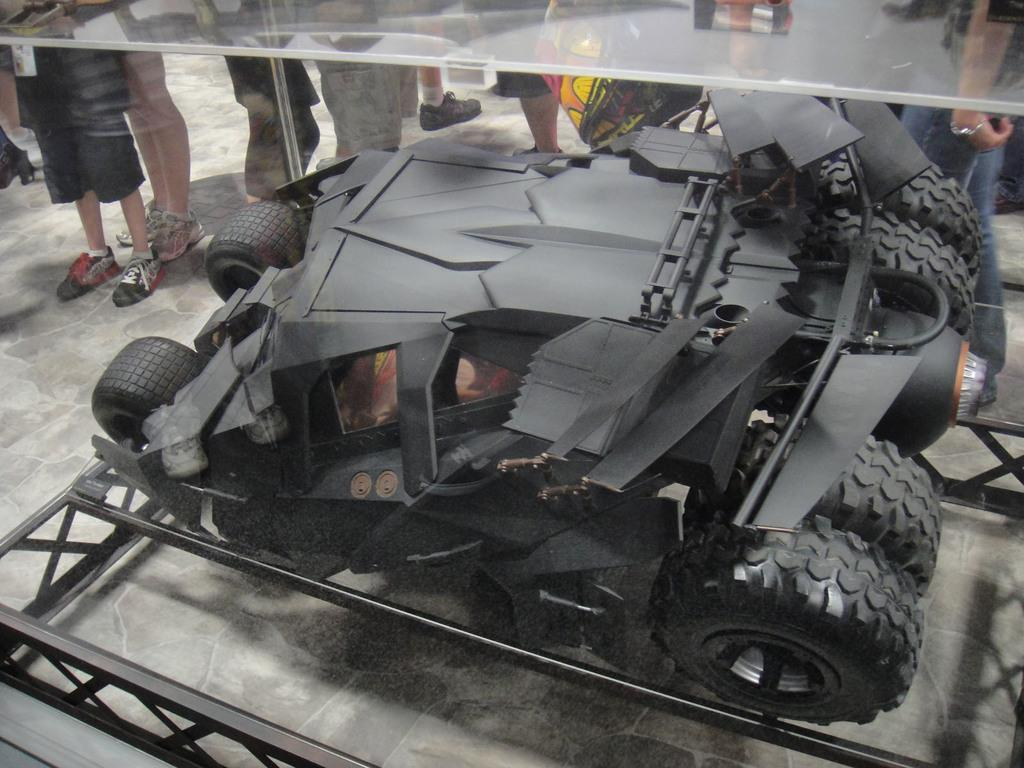How many people are in the image? There are persons in the image, but the exact number cannot be determined from the provided facts. What object can be seen in the image that is typically used for drinking? There is a glass in the image. What type of vehicle is present in the image? There is a vehicle in the image, but the specific type cannot be determined from the provided facts. What type of egg is being cracked on the person's chin in the image? There is no egg or chin present in the image; it only features persons, a glass, and a vehicle. 